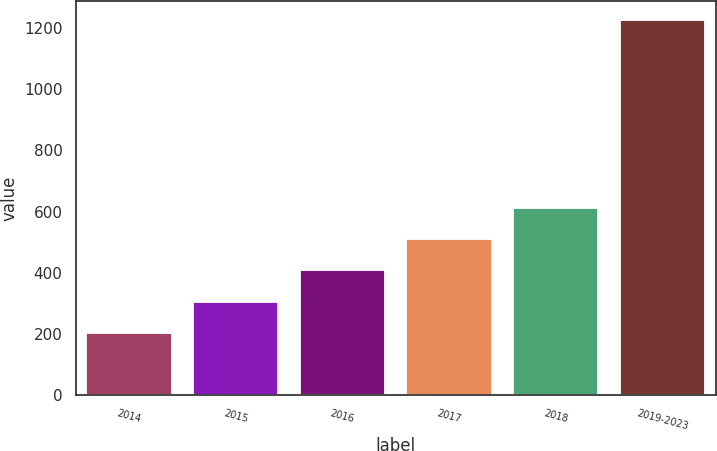<chart> <loc_0><loc_0><loc_500><loc_500><bar_chart><fcel>2014<fcel>2015<fcel>2016<fcel>2017<fcel>2018<fcel>2019-2023<nl><fcel>202<fcel>304.6<fcel>407.2<fcel>509.8<fcel>612.4<fcel>1228<nl></chart> 